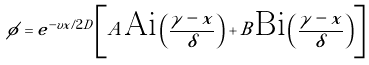Convert formula to latex. <formula><loc_0><loc_0><loc_500><loc_500>\phi = e ^ { - v x / 2 D } \left [ A { \text {Ai} } \left ( \frac { \gamma - x } { \delta } \right ) + B { \text {Bi} } \left ( \frac { \gamma - x } { \delta } \right ) \right ]</formula> 